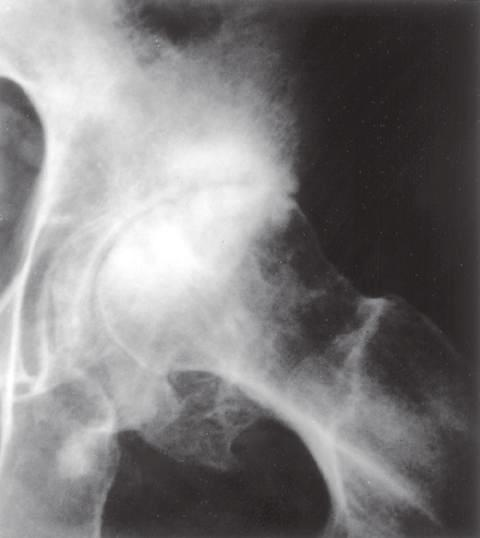s there subchondral sclerosis with scattered oval radiolucent cysts and peripheral osteophyte lipping (arrows)?
Answer the question using a single word or phrase. Yes 